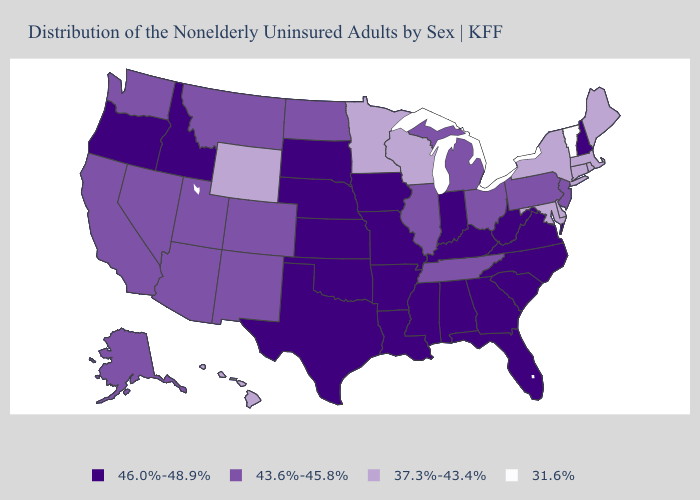What is the value of Tennessee?
Short answer required. 43.6%-45.8%. Among the states that border Wisconsin , does Minnesota have the lowest value?
Answer briefly. Yes. Name the states that have a value in the range 37.3%-43.4%?
Be succinct. Connecticut, Delaware, Hawaii, Maine, Maryland, Massachusetts, Minnesota, New York, Rhode Island, Wisconsin, Wyoming. Name the states that have a value in the range 46.0%-48.9%?
Answer briefly. Alabama, Arkansas, Florida, Georgia, Idaho, Indiana, Iowa, Kansas, Kentucky, Louisiana, Mississippi, Missouri, Nebraska, New Hampshire, North Carolina, Oklahoma, Oregon, South Carolina, South Dakota, Texas, Virginia, West Virginia. Does Oklahoma have a higher value than Texas?
Concise answer only. No. What is the value of Tennessee?
Give a very brief answer. 43.6%-45.8%. What is the highest value in the West ?
Short answer required. 46.0%-48.9%. What is the value of Oklahoma?
Be succinct. 46.0%-48.9%. Does Delaware have the lowest value in the South?
Give a very brief answer. Yes. Does Wyoming have the highest value in the West?
Short answer required. No. Which states hav the highest value in the MidWest?
Write a very short answer. Indiana, Iowa, Kansas, Missouri, Nebraska, South Dakota. What is the lowest value in the USA?
Write a very short answer. 31.6%. What is the value of West Virginia?
Give a very brief answer. 46.0%-48.9%. Does the first symbol in the legend represent the smallest category?
Concise answer only. No. What is the lowest value in states that border Mississippi?
Write a very short answer. 43.6%-45.8%. 